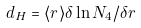<formula> <loc_0><loc_0><loc_500><loc_500>d _ { H } = \langle r \rangle \delta \ln { N _ { 4 } } / \delta r</formula> 